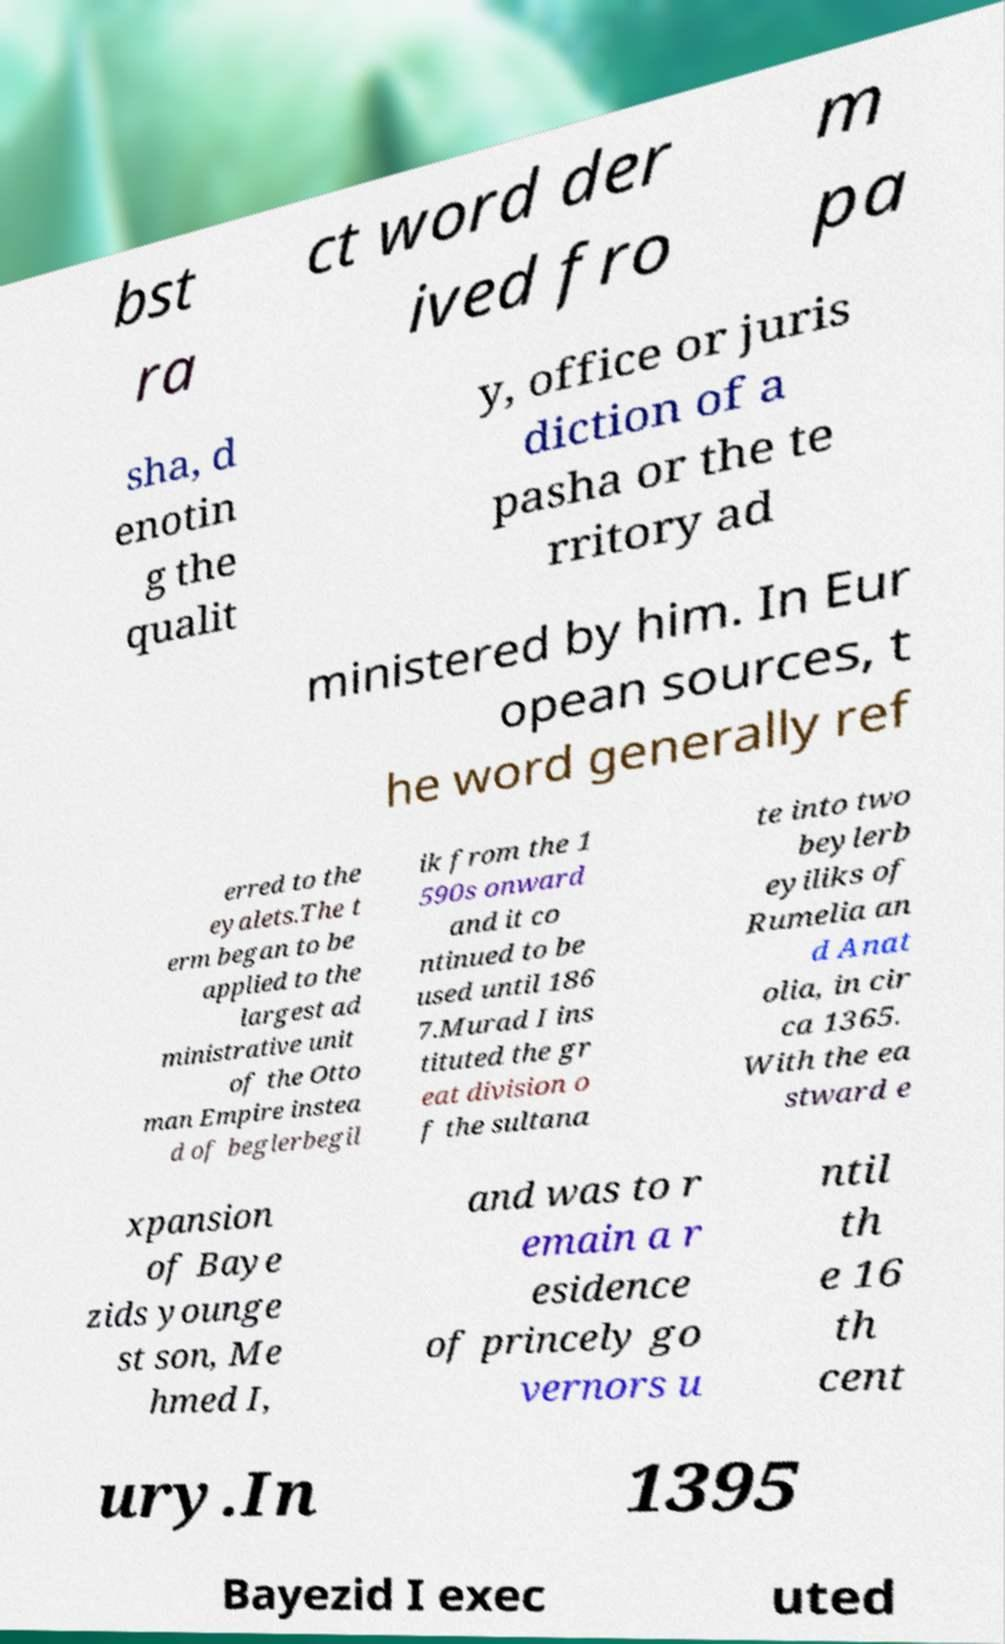For documentation purposes, I need the text within this image transcribed. Could you provide that? bst ra ct word der ived fro m pa sha, d enotin g the qualit y, office or juris diction of a pasha or the te rritory ad ministered by him. In Eur opean sources, t he word generally ref erred to the eyalets.The t erm began to be applied to the largest ad ministrative unit of the Otto man Empire instea d of beglerbegil ik from the 1 590s onward and it co ntinued to be used until 186 7.Murad I ins tituted the gr eat division o f the sultana te into two beylerb eyiliks of Rumelia an d Anat olia, in cir ca 1365. With the ea stward e xpansion of Baye zids younge st son, Me hmed I, and was to r emain a r esidence of princely go vernors u ntil th e 16 th cent ury.In 1395 Bayezid I exec uted 